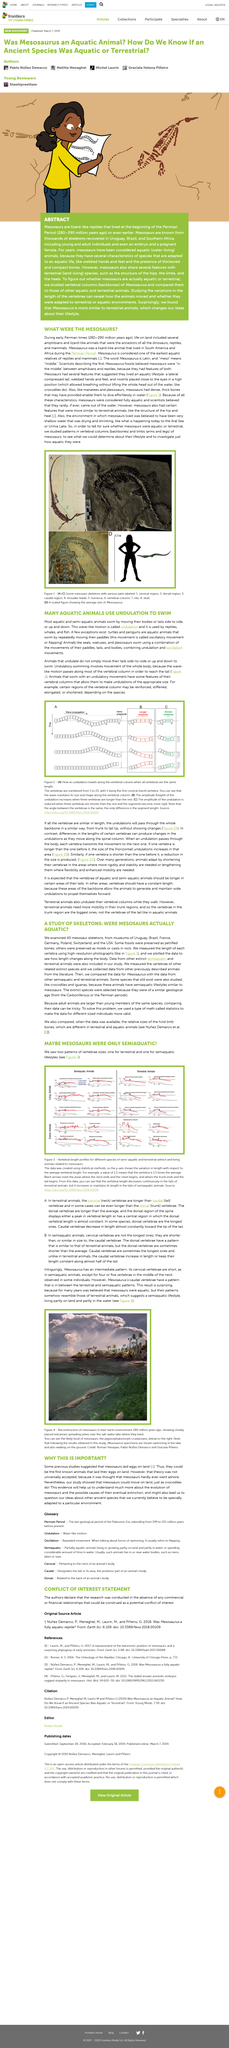Draw attention to some important aspects in this diagram. The Mesosaurus vertebrae were generally short in length. The image depicts a swimming animal that is identified as Mesosaurus. The vertebral patterns of Mesosaurus indicate that it had a semi-aquatic lifestyle. The pictures A, B, and C depict mesosaur skeletons. The article's title is "WHAT WERE THE MESOSAURS?" 